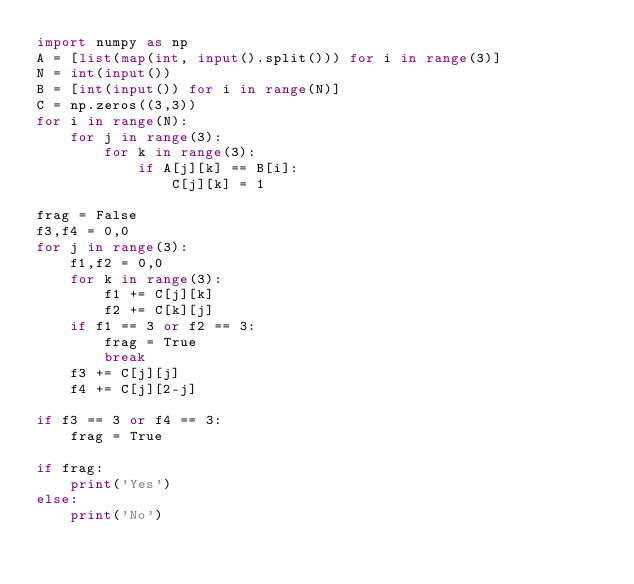<code> <loc_0><loc_0><loc_500><loc_500><_Python_>import numpy as np 
A = [list(map(int, input().split())) for i in range(3)] 
N = int(input()) 
B = [int(input()) for i in range(N)]
C = np.zeros((3,3))
for i in range(N):
    for j in range(3):
        for k in range(3):
            if A[j][k] == B[i]:
                C[j][k] = 1
                
frag = False
f3,f4 = 0,0
for j in range(3):
    f1,f2 = 0,0 
    for k in range(3):
        f1 += C[j][k]
        f2 += C[k][j]
    if f1 == 3 or f2 == 3:
        frag = True
        break 
    f3 += C[j][j] 
    f4 += C[j][2-j]
    
if f3 == 3 or f4 == 3:
    frag = True
    
if frag:
    print('Yes')
else:
    print('No')</code> 